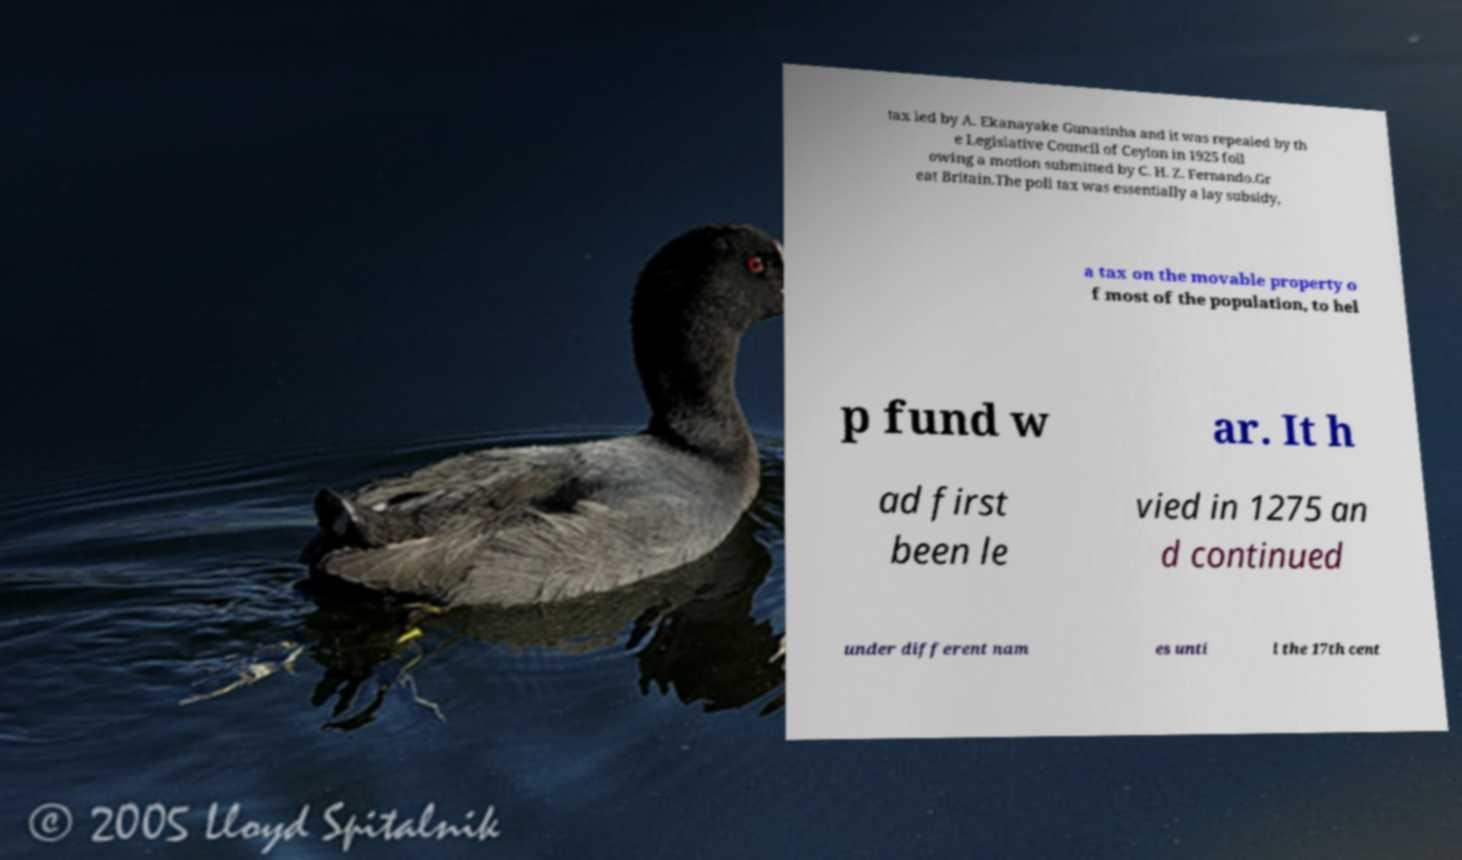Please read and relay the text visible in this image. What does it say? tax led by A. Ekanayake Gunasinha and it was repealed by th e Legislative Council of Ceylon in 1925 foll owing a motion submitted by C. H. Z. Fernando.Gr eat Britain.The poll tax was essentially a lay subsidy, a tax on the movable property o f most of the population, to hel p fund w ar. It h ad first been le vied in 1275 an d continued under different nam es unti l the 17th cent 